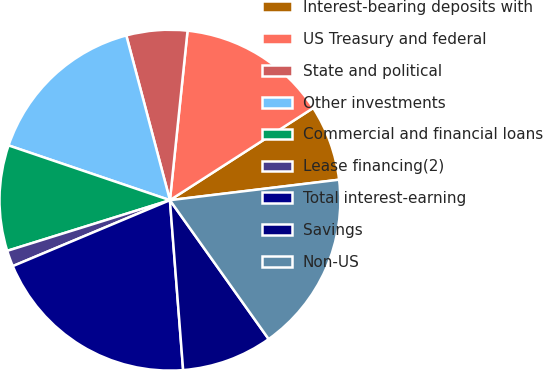<chart> <loc_0><loc_0><loc_500><loc_500><pie_chart><fcel>Interest-bearing deposits with<fcel>US Treasury and federal<fcel>State and political<fcel>Other investments<fcel>Commercial and financial loans<fcel>Lease financing(2)<fcel>Total interest-earning<fcel>Savings<fcel>Non-US<nl><fcel>7.18%<fcel>14.25%<fcel>5.77%<fcel>15.67%<fcel>10.01%<fcel>1.52%<fcel>19.91%<fcel>8.6%<fcel>17.08%<nl></chart> 